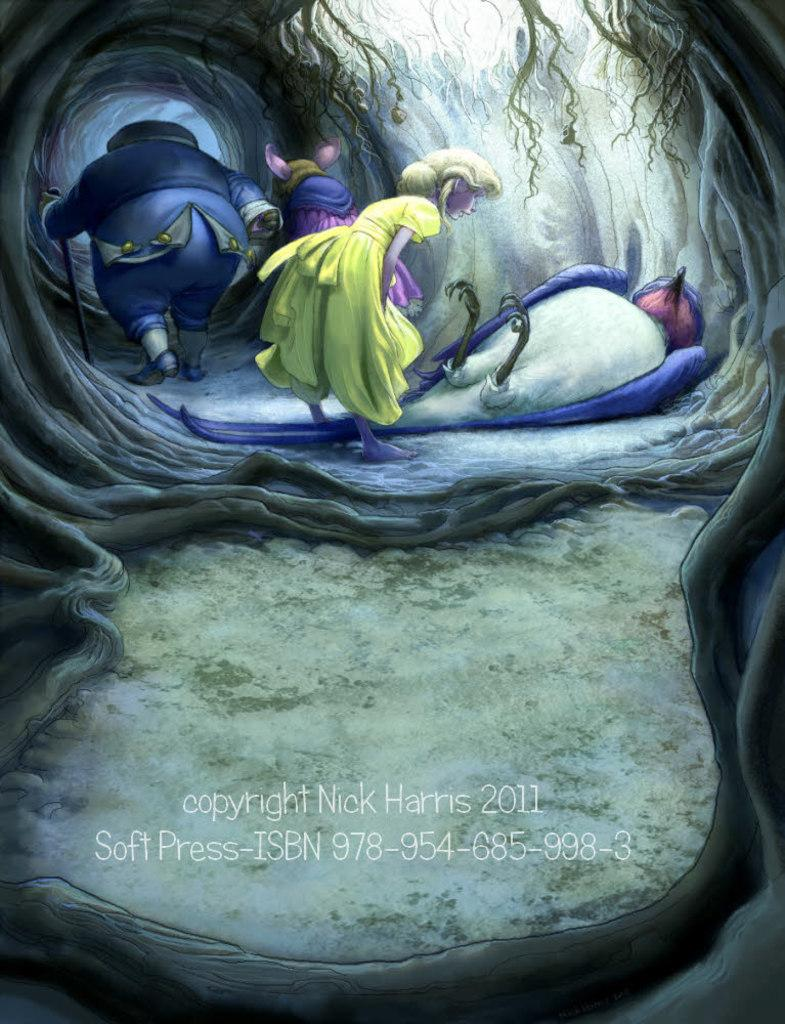What type of image is shown in the picture? The image contains a cartoon picture. Can you describe the people in the image? There is a person standing in front wearing a yellow frock, and there is a person at the back wearing a blue dress. What is the person at the back holding? The person at the back is holding a stick. What type of flowers can be seen growing near the drain in the image? There are no flowers or drains present in the image; it contains a cartoon picture of two people with a stick. 